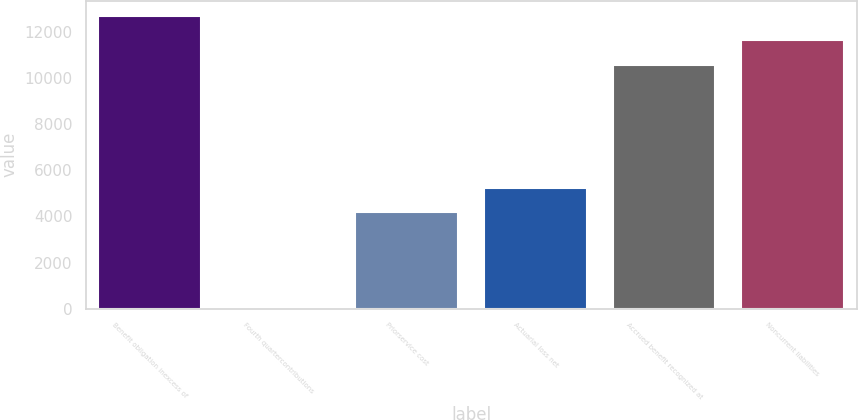Convert chart to OTSL. <chart><loc_0><loc_0><loc_500><loc_500><bar_chart><fcel>Benefit obligation inexcess of<fcel>Fourth quartercontributions<fcel>Priorservice cost<fcel>Actuarial loss net<fcel>Accrued benefit recognized at<fcel>Noncurrent liabilities<nl><fcel>12694.6<fcel>66<fcel>4175<fcel>5241.3<fcel>10562<fcel>11628.3<nl></chart> 